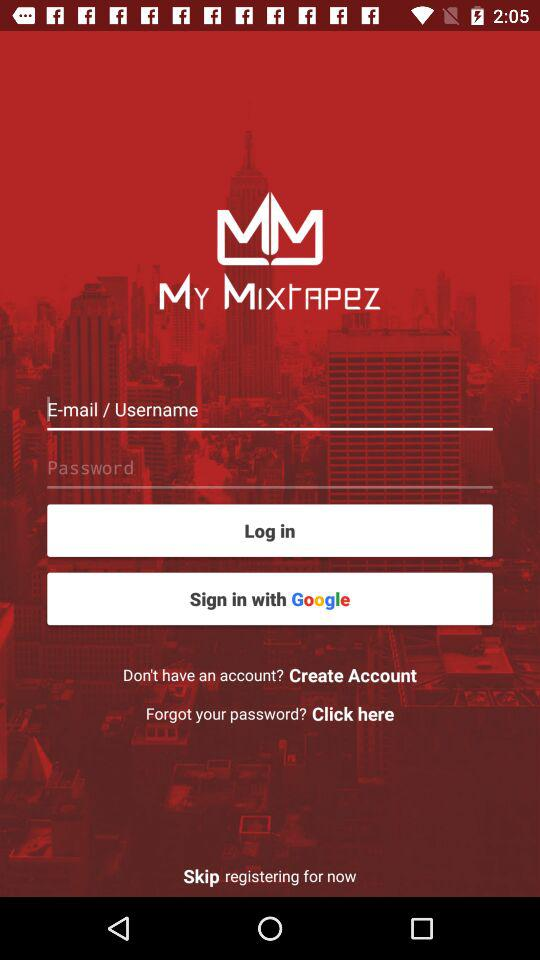What account can be used to login? You can login with "Google". 